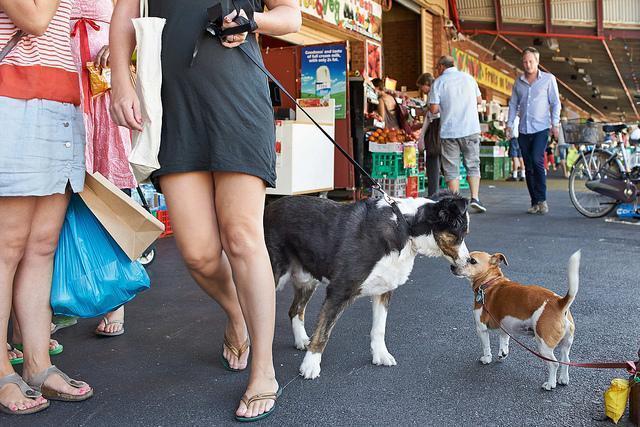How many dogs are visible?
Give a very brief answer. 2. How many handbags are there?
Give a very brief answer. 2. How many people are in the photo?
Give a very brief answer. 6. How many juvenile giraffes are in this picture?
Give a very brief answer. 0. 